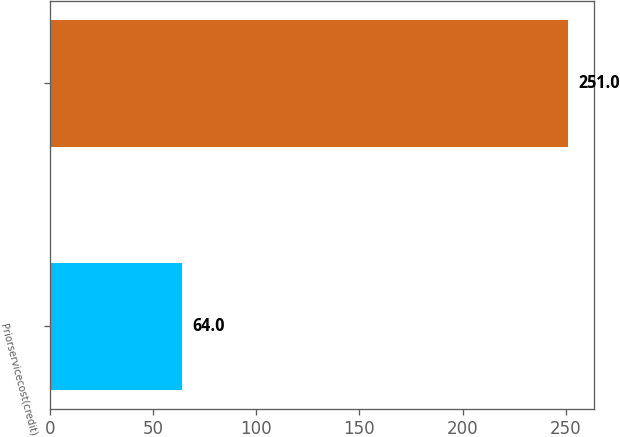Convert chart to OTSL. <chart><loc_0><loc_0><loc_500><loc_500><bar_chart><fcel>Priorservicecost(credit)<fcel>Unnamed: 1<nl><fcel>64<fcel>251<nl></chart> 